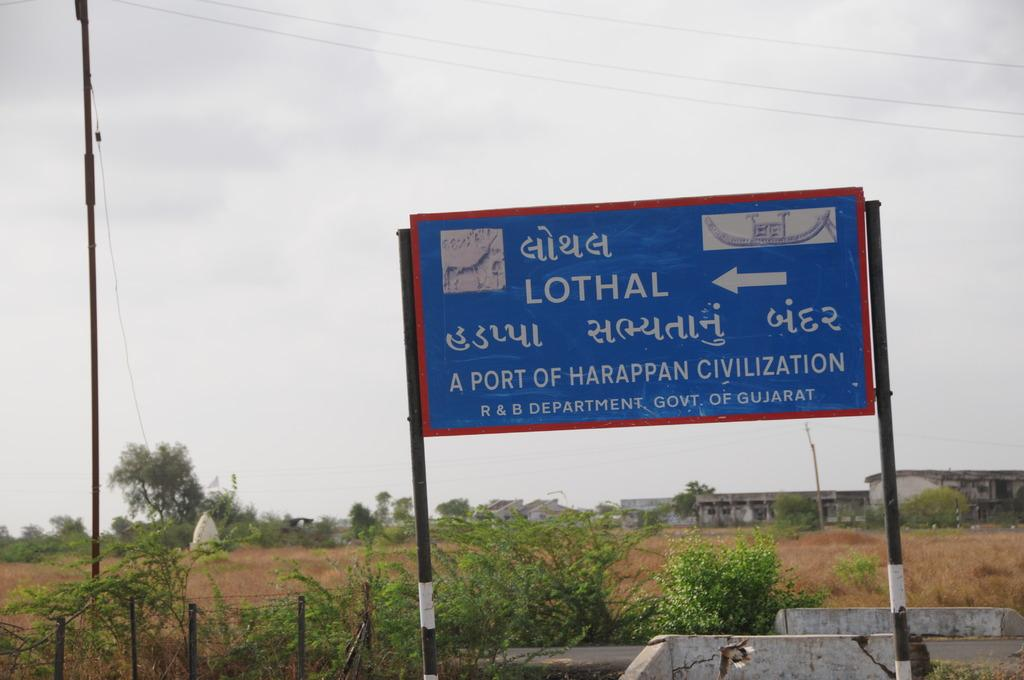Provide a one-sentence caption for the provided image. A blue billboard covered in many languages, and an arrow pointing to a town called Lothal. 